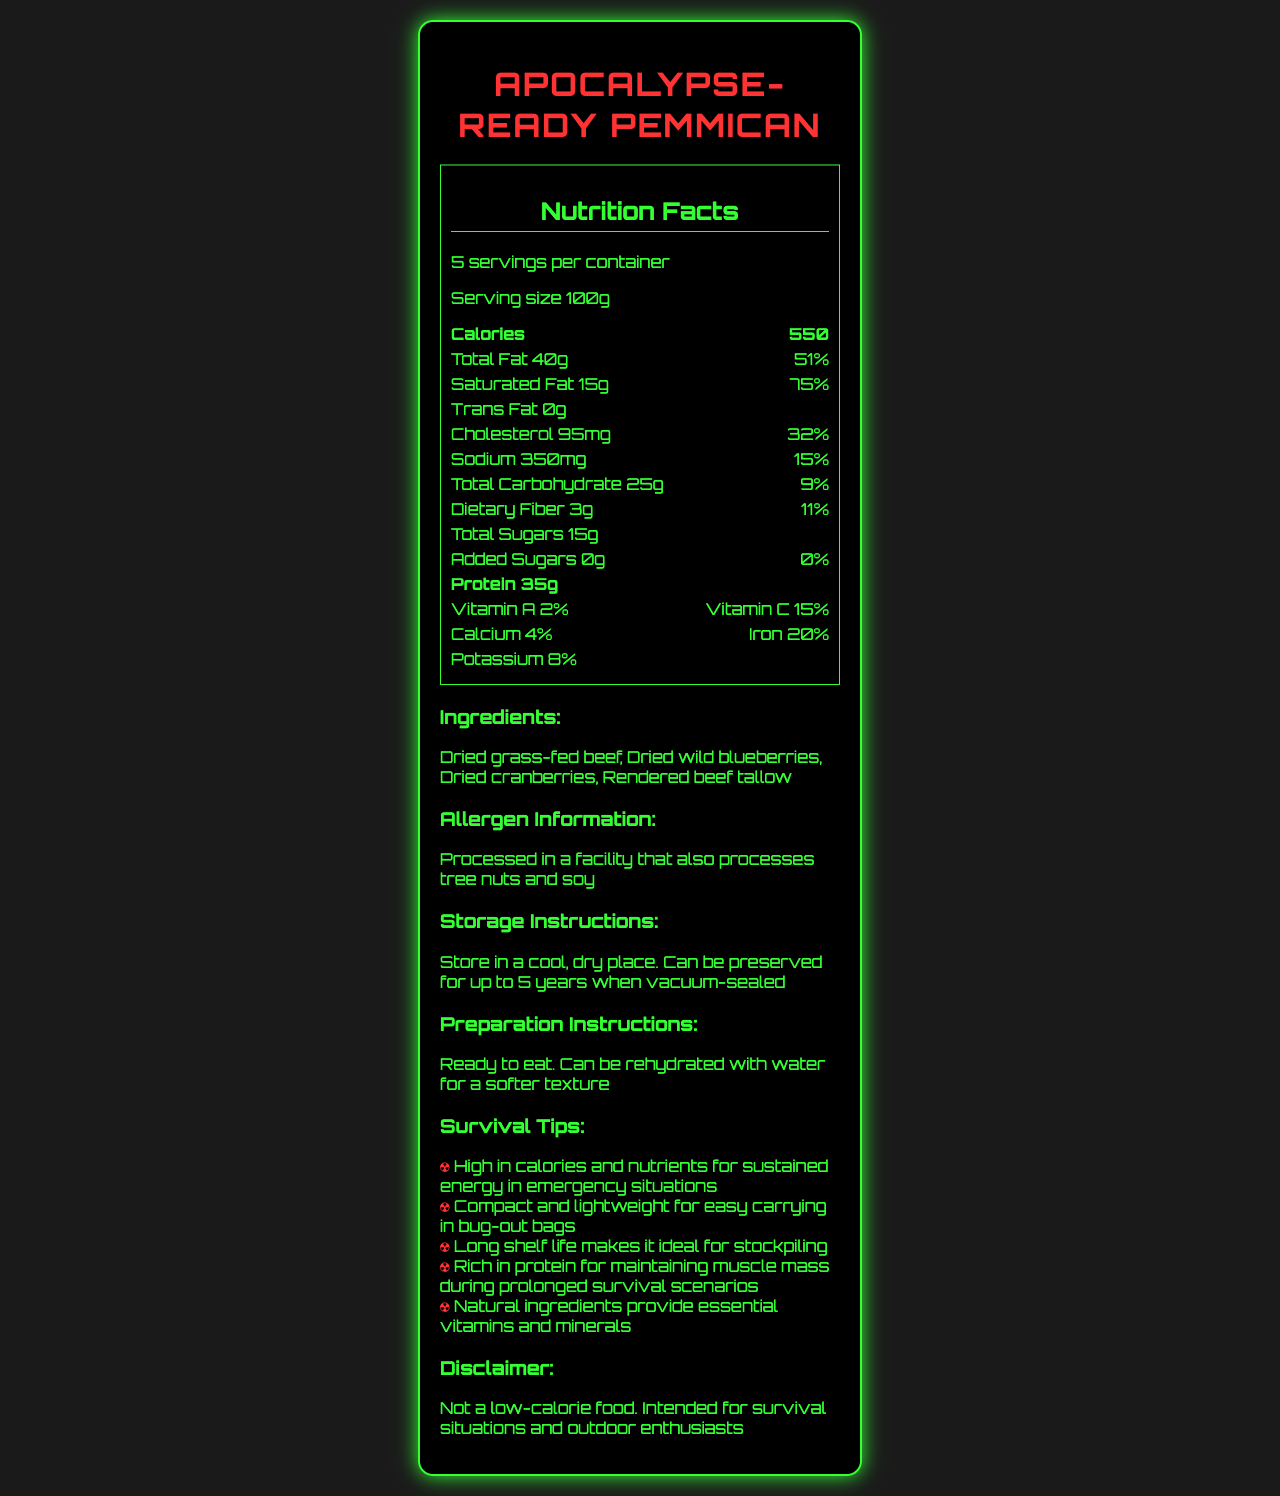what is the serving size for Apocalypse-Ready Pemmican? The document specifies the serving size directly as "100g".
Answer: 100g how many calories are in one serving? The document lists the number of calories per serving as "550".
Answer: 550 how much protein is in one serving of this pemmican? The document mentions that each serving contains "35g" of protein.
Answer: 35g how many servings are in one container? According to the document, there are "5 servings per container".
Answer: 5 what percentage of the daily value of saturated fat is provided by one serving? The document states that the saturated fat daily value is "75%".
Answer: 75% Which of the following is NOT an ingredient in Apocalypse-Ready Pemmican? 1. Dried grass-fed beef 2. Dried wild blueberries 3. Rendered beef tallow 4. Almond flour The list of ingredients in the document includes dried grass-fed beef, dried wild blueberries, and rendered beef tallow, but not almond flour.
Answer: 4. Almond flour Apocalypse-Ready Pemmican provides what percentage of the daily value for iron? A. 4% B. 8% C. 15% D. 20% The document lists the iron daily value as "20%".
Answer: D. 20% Does one serving of this pemmican contain any trans fat? The document states "Trans Fat 0g", indicating it contains no trans fat.
Answer: No summarize the main benefits of Apocalypse-Ready Pemmican mentioned in the document. The document highlights that the pemmican is high in calories and nutrients for sustained energy, has a long shelf life, is lightweight for easy carrying, and is rich in protein for maintaining muscle mass.
Answer: High calories and nutrients, long shelf life, lightweight, and rich in protein Can the protein content of the whole container be determined based on the given information? The document states that one serving has 35g of protein, and there are 5 servings per container. Thus, the whole container has 35g x 5 = 175g of protein.
Answer: Yes what is the daily value percentage for sodium in one serving? The document lists the sodium daily value as "15%".
Answer: 15% how long can the pemmican be preserved when vacuum-sealed? The document's storage instructions state that it can be preserved for up to 5 years when vacuum-sealed.
Answer: up to 5 years what two vitamins are included in the nutritional information? The document mentions Vitamin A at 2% and Vitamin C at 15%.
Answer: Vitamin A and Vitamin C In which type of facility is the pemmican processed? The allergen information section mentions that it is processed in a facility that also processes tree nuts and soy.
Answer: A facility that also processes tree nuts and soy How many grams of dietary fiber is there per serving of Apocalypse-Ready Pemmican? The document indicates that there are 3g of dietary fiber per serving.
Answer: 3g Does the document provide specific information about the origins of the blueberries used in the pemmican? There is no specific information about the origins of the blueberries, only that they are "dried wild blueberries".
Answer: No 